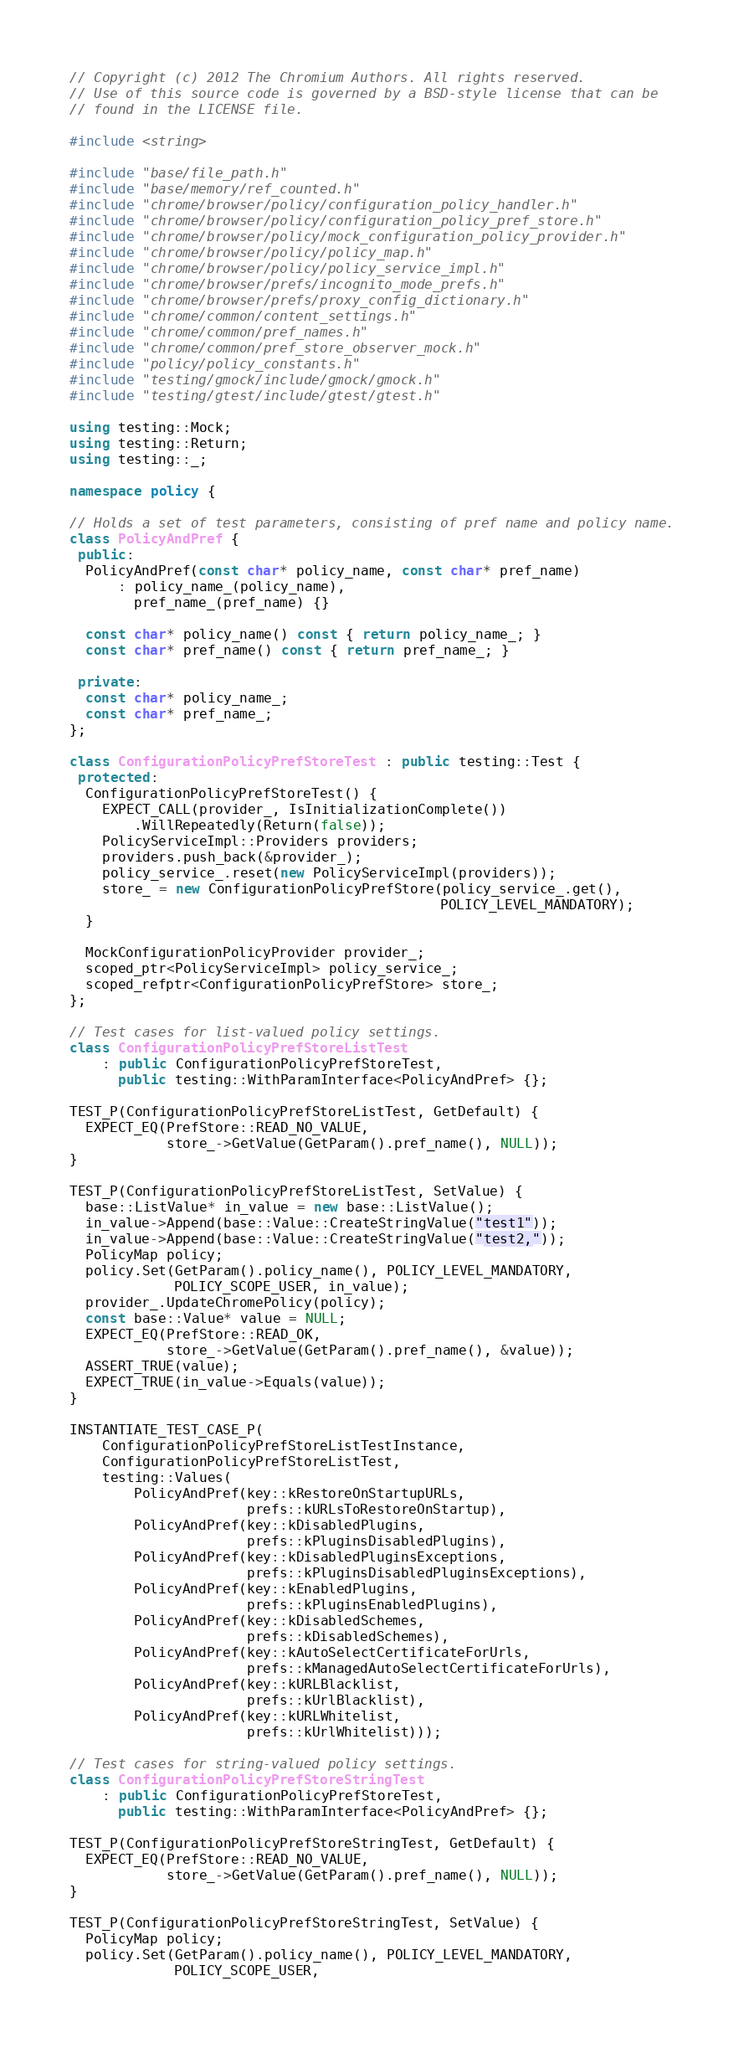<code> <loc_0><loc_0><loc_500><loc_500><_C++_>// Copyright (c) 2012 The Chromium Authors. All rights reserved.
// Use of this source code is governed by a BSD-style license that can be
// found in the LICENSE file.

#include <string>

#include "base/file_path.h"
#include "base/memory/ref_counted.h"
#include "chrome/browser/policy/configuration_policy_handler.h"
#include "chrome/browser/policy/configuration_policy_pref_store.h"
#include "chrome/browser/policy/mock_configuration_policy_provider.h"
#include "chrome/browser/policy/policy_map.h"
#include "chrome/browser/policy/policy_service_impl.h"
#include "chrome/browser/prefs/incognito_mode_prefs.h"
#include "chrome/browser/prefs/proxy_config_dictionary.h"
#include "chrome/common/content_settings.h"
#include "chrome/common/pref_names.h"
#include "chrome/common/pref_store_observer_mock.h"
#include "policy/policy_constants.h"
#include "testing/gmock/include/gmock/gmock.h"
#include "testing/gtest/include/gtest/gtest.h"

using testing::Mock;
using testing::Return;
using testing::_;

namespace policy {

// Holds a set of test parameters, consisting of pref name and policy name.
class PolicyAndPref {
 public:
  PolicyAndPref(const char* policy_name, const char* pref_name)
      : policy_name_(policy_name),
        pref_name_(pref_name) {}

  const char* policy_name() const { return policy_name_; }
  const char* pref_name() const { return pref_name_; }

 private:
  const char* policy_name_;
  const char* pref_name_;
};

class ConfigurationPolicyPrefStoreTest : public testing::Test {
 protected:
  ConfigurationPolicyPrefStoreTest() {
    EXPECT_CALL(provider_, IsInitializationComplete())
        .WillRepeatedly(Return(false));
    PolicyServiceImpl::Providers providers;
    providers.push_back(&provider_);
    policy_service_.reset(new PolicyServiceImpl(providers));
    store_ = new ConfigurationPolicyPrefStore(policy_service_.get(),
                                              POLICY_LEVEL_MANDATORY);
  }

  MockConfigurationPolicyProvider provider_;
  scoped_ptr<PolicyServiceImpl> policy_service_;
  scoped_refptr<ConfigurationPolicyPrefStore> store_;
};

// Test cases for list-valued policy settings.
class ConfigurationPolicyPrefStoreListTest
    : public ConfigurationPolicyPrefStoreTest,
      public testing::WithParamInterface<PolicyAndPref> {};

TEST_P(ConfigurationPolicyPrefStoreListTest, GetDefault) {
  EXPECT_EQ(PrefStore::READ_NO_VALUE,
            store_->GetValue(GetParam().pref_name(), NULL));
}

TEST_P(ConfigurationPolicyPrefStoreListTest, SetValue) {
  base::ListValue* in_value = new base::ListValue();
  in_value->Append(base::Value::CreateStringValue("test1"));
  in_value->Append(base::Value::CreateStringValue("test2,"));
  PolicyMap policy;
  policy.Set(GetParam().policy_name(), POLICY_LEVEL_MANDATORY,
             POLICY_SCOPE_USER, in_value);
  provider_.UpdateChromePolicy(policy);
  const base::Value* value = NULL;
  EXPECT_EQ(PrefStore::READ_OK,
            store_->GetValue(GetParam().pref_name(), &value));
  ASSERT_TRUE(value);
  EXPECT_TRUE(in_value->Equals(value));
}

INSTANTIATE_TEST_CASE_P(
    ConfigurationPolicyPrefStoreListTestInstance,
    ConfigurationPolicyPrefStoreListTest,
    testing::Values(
        PolicyAndPref(key::kRestoreOnStartupURLs,
                      prefs::kURLsToRestoreOnStartup),
        PolicyAndPref(key::kDisabledPlugins,
                      prefs::kPluginsDisabledPlugins),
        PolicyAndPref(key::kDisabledPluginsExceptions,
                      prefs::kPluginsDisabledPluginsExceptions),
        PolicyAndPref(key::kEnabledPlugins,
                      prefs::kPluginsEnabledPlugins),
        PolicyAndPref(key::kDisabledSchemes,
                      prefs::kDisabledSchemes),
        PolicyAndPref(key::kAutoSelectCertificateForUrls,
                      prefs::kManagedAutoSelectCertificateForUrls),
        PolicyAndPref(key::kURLBlacklist,
                      prefs::kUrlBlacklist),
        PolicyAndPref(key::kURLWhitelist,
                      prefs::kUrlWhitelist)));

// Test cases for string-valued policy settings.
class ConfigurationPolicyPrefStoreStringTest
    : public ConfigurationPolicyPrefStoreTest,
      public testing::WithParamInterface<PolicyAndPref> {};

TEST_P(ConfigurationPolicyPrefStoreStringTest, GetDefault) {
  EXPECT_EQ(PrefStore::READ_NO_VALUE,
            store_->GetValue(GetParam().pref_name(), NULL));
}

TEST_P(ConfigurationPolicyPrefStoreStringTest, SetValue) {
  PolicyMap policy;
  policy.Set(GetParam().policy_name(), POLICY_LEVEL_MANDATORY,
             POLICY_SCOPE_USER,</code> 